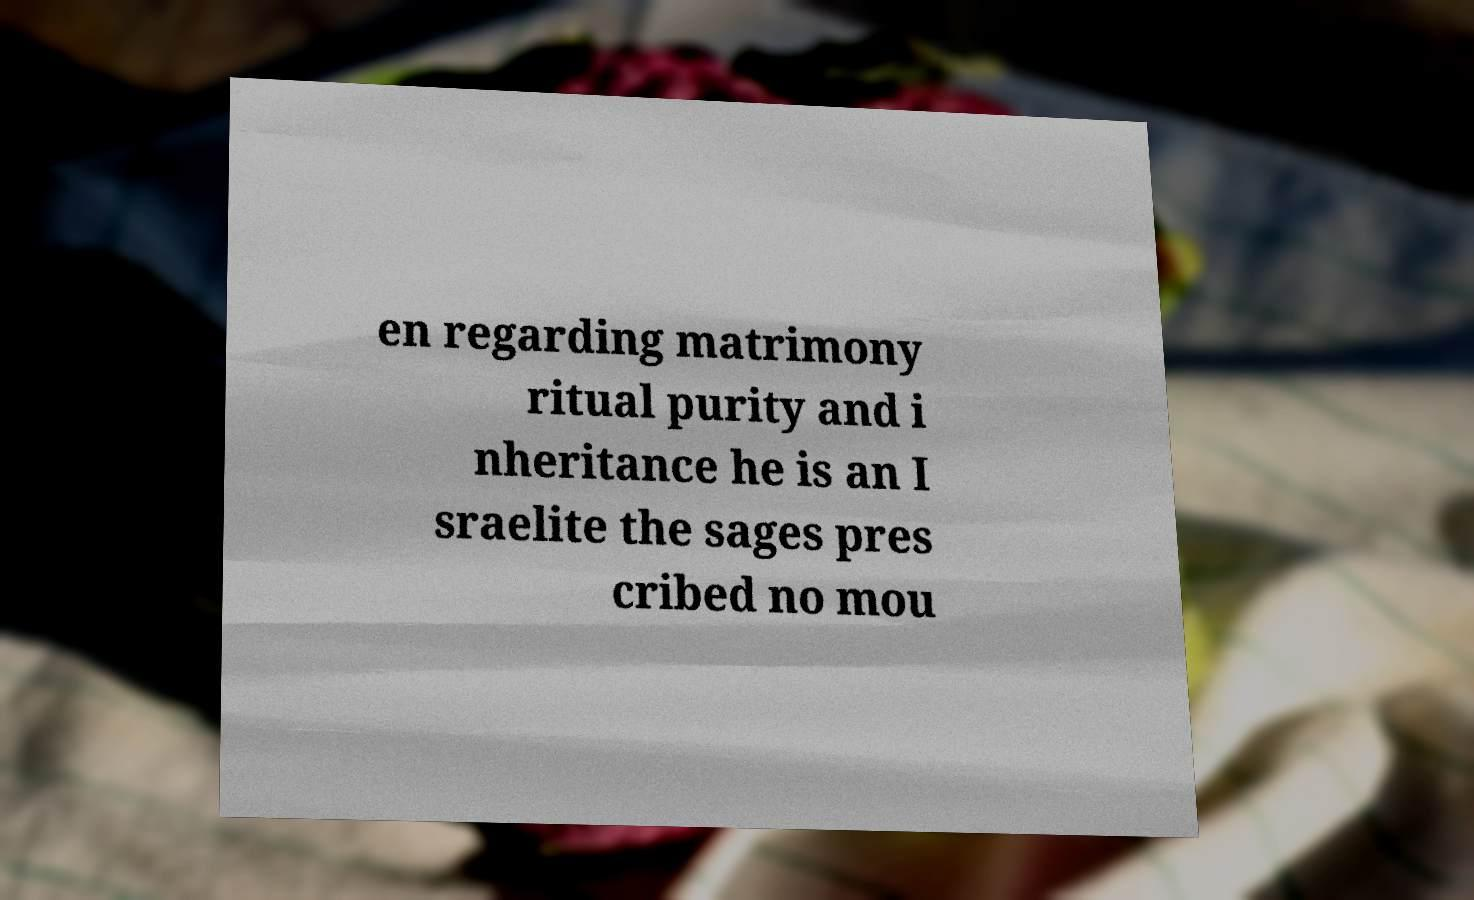Can you accurately transcribe the text from the provided image for me? en regarding matrimony ritual purity and i nheritance he is an I sraelite the sages pres cribed no mou 